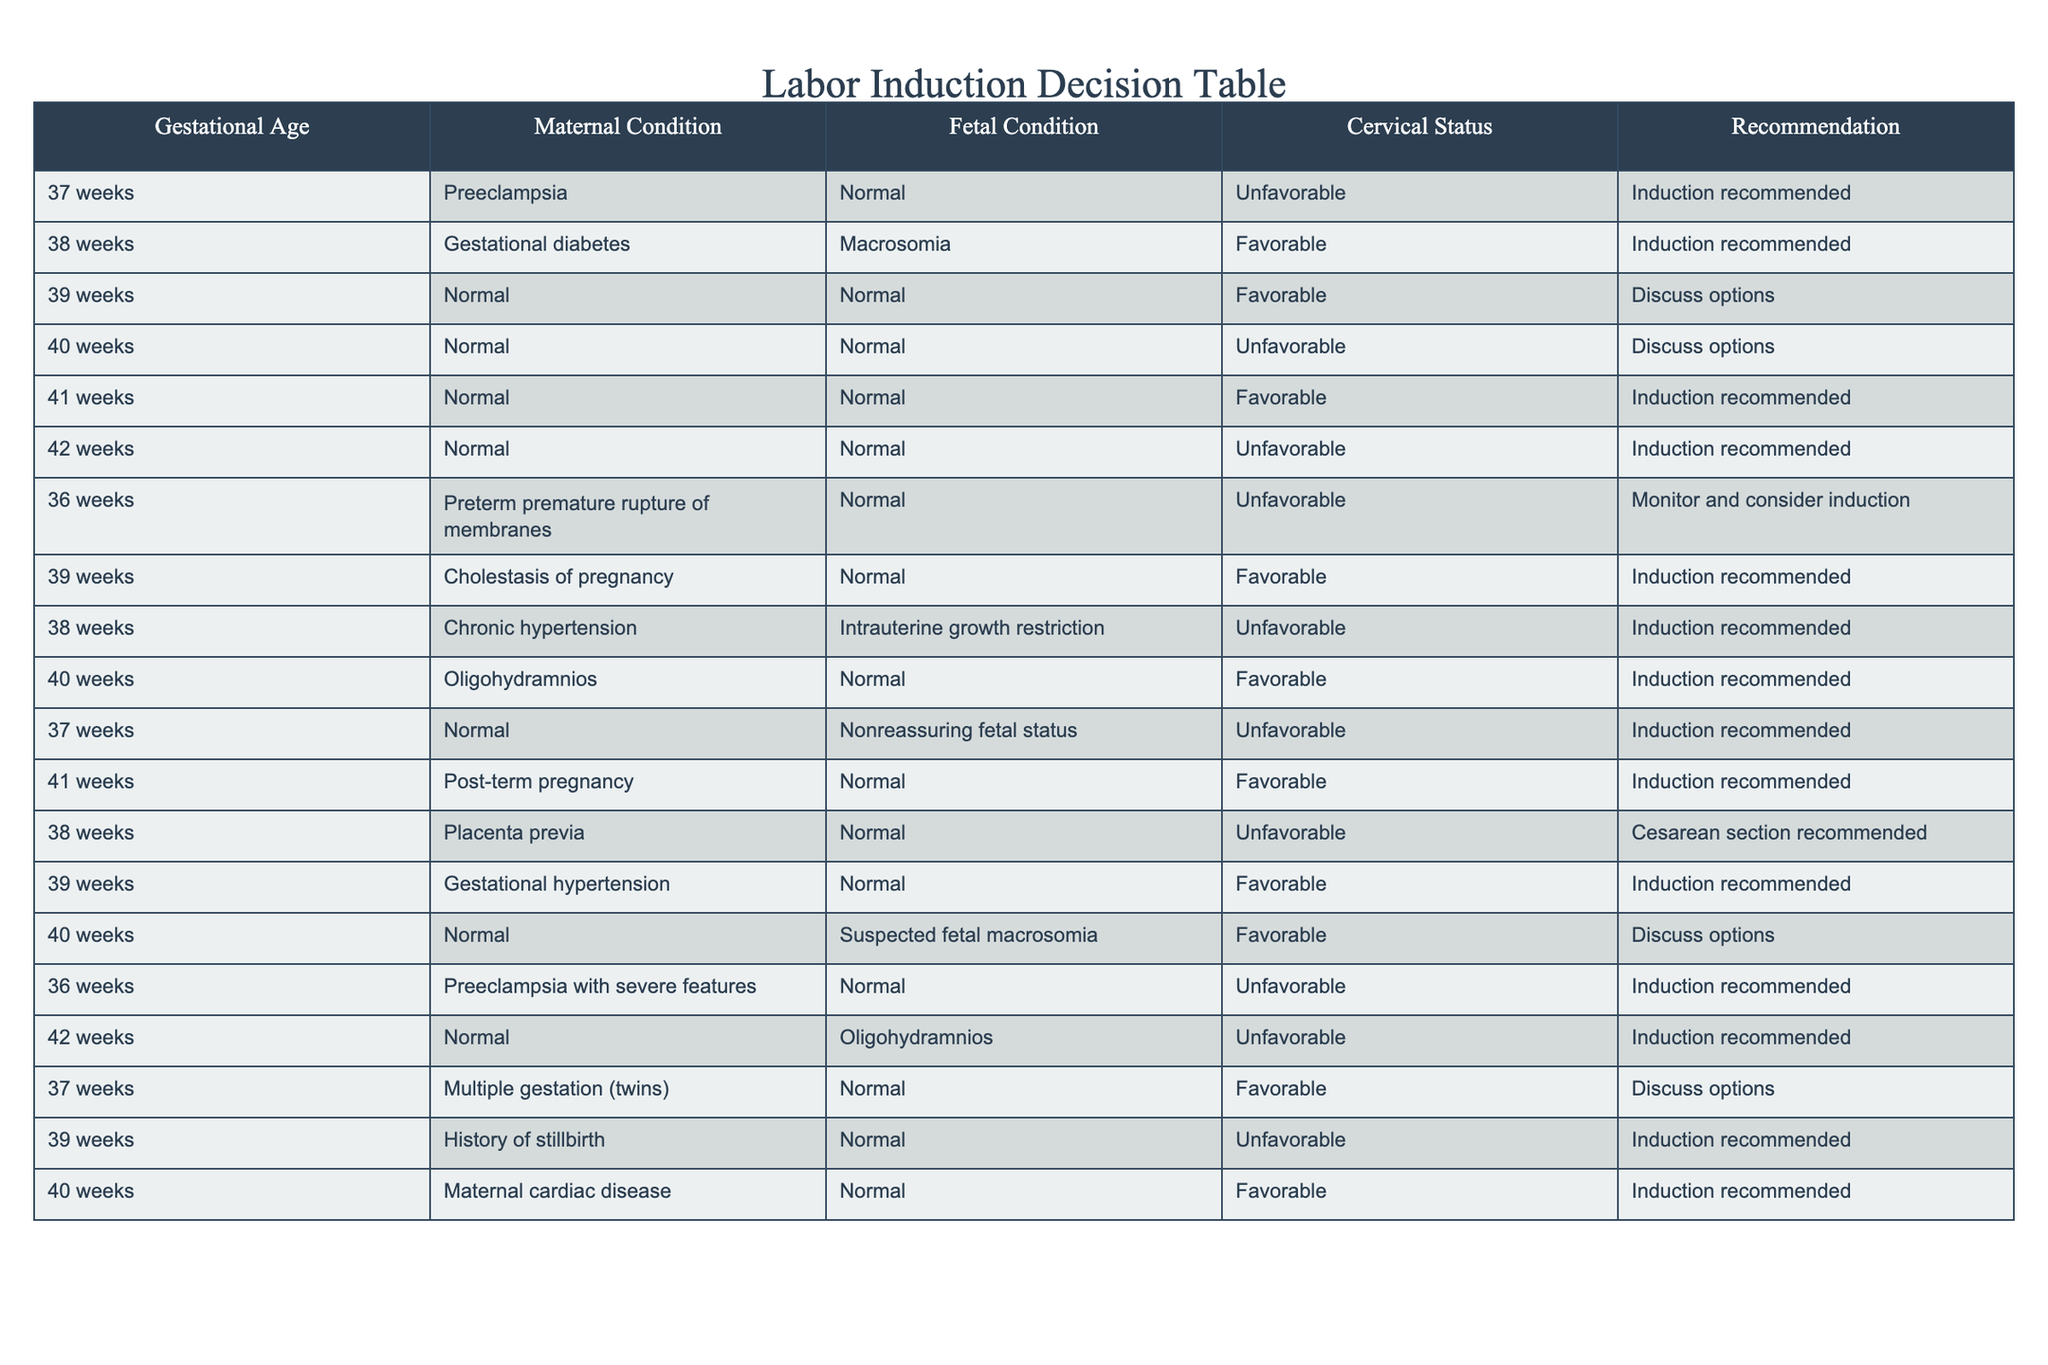What is the recommendation for induction of labor at 37 weeks with unfavorable cervical status? According to the table, for 37 weeks with a maternal condition of preeclampsia, a fetal condition of normal, and unfavorable cervical status, the recommendation is for induction.
Answer: Induction recommended How many entries recommend induction at 39 weeks? In the table, the entries for 39 weeks that recommend induction are for gestational hypertension, cholestasis of pregnancy, and a history of stillbirth. There are a total of three recommendations at this gestational age.
Answer: 3 Is induction recommended for normal fetal conditions at 40 weeks? For 40 weeks with a normal fetal condition, there is one entry with favorable cervical status recommending induction and another entry with unfavorable cervical status recommending a discussion of options. Therefore, the answer is no induction is not uniformly recommended for 40 weeks.
Answer: No What are the maternal conditions associated with a recommendation for induction at 42 weeks? The table shows that there are two entries for 42 weeks: one with a maternal condition of normal, and another with a maternal condition of oligohydramnios. Therefore, the maternal conditions associated with a recommendation for induction at this gestational age are normal and oligohydramnios.
Answer: Normal, Oligohydramnios Which gestational ages have a recommendation for cesarean section? The only entry in the table that suggests a cesarean section is for 38 weeks with a maternal condition of placenta previa. This indicates that the only gestational age with this recommendation is 38 weeks.
Answer: 38 weeks At what gestational age is induction recommended for preeclampsia with severe features? The table indicates that preeclampsia with severe features is only included in the entry for 36 weeks, where induction is also recommended.
Answer: 36 weeks What is the cervical status for the case of gestational diabetes at 38 weeks and what is the recommendation? The entry for gestational diabetes at 38 weeks has a favorable cervical status, and the recommendation for this scenario is for induction.
Answer: Favorable, Induction recommended How many total recommendations for induction are listed for unfavorable cervical status? By reviewing the table, the entries with unfavorable cervical status include those for 37 weeks (preeclampsia), 38 weeks (chronic hypertension), 36 weeks (preterm premature rupture of membranes), and 42 weeks (oligohydramnios), totaling four recommendations for induction associated with unfavorable cervical status.
Answer: 4 